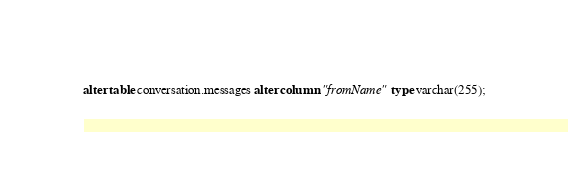<code> <loc_0><loc_0><loc_500><loc_500><_SQL_>alter table conversation.messages alter column "fromName" type varchar(255);</code> 